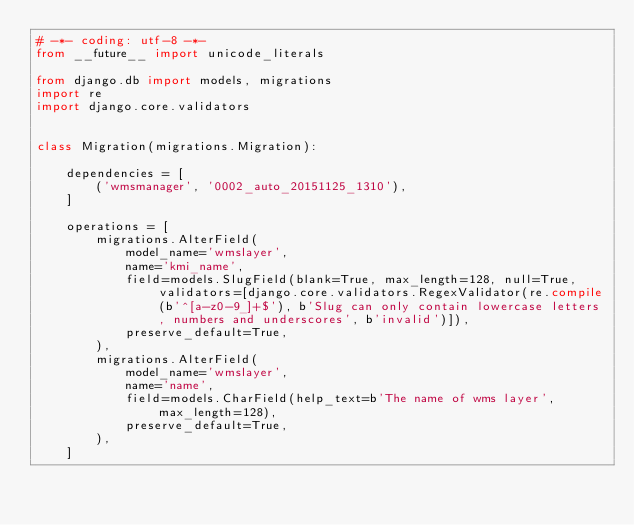Convert code to text. <code><loc_0><loc_0><loc_500><loc_500><_Python_># -*- coding: utf-8 -*-
from __future__ import unicode_literals

from django.db import models, migrations
import re
import django.core.validators


class Migration(migrations.Migration):

    dependencies = [
        ('wmsmanager', '0002_auto_20151125_1310'),
    ]

    operations = [
        migrations.AlterField(
            model_name='wmslayer',
            name='kmi_name',
            field=models.SlugField(blank=True, max_length=128, null=True, validators=[django.core.validators.RegexValidator(re.compile(b'^[a-z0-9_]+$'), b'Slug can only contain lowercase letters, numbers and underscores', b'invalid')]),
            preserve_default=True,
        ),
        migrations.AlterField(
            model_name='wmslayer',
            name='name',
            field=models.CharField(help_text=b'The name of wms layer', max_length=128),
            preserve_default=True,
        ),
    ]
</code> 